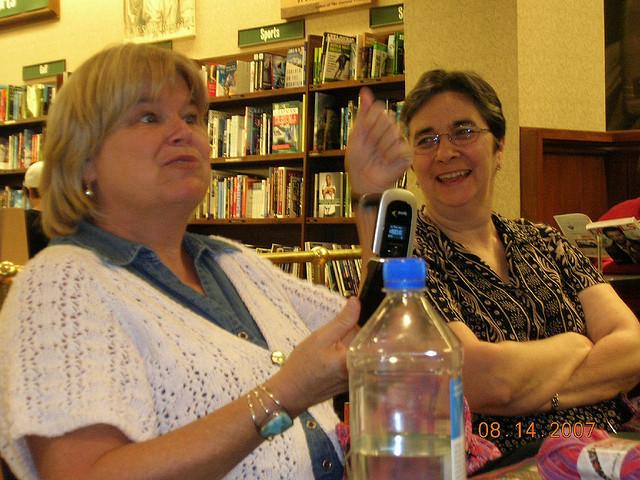Is anyone wearing earrings?
Short answer required. Yes. How old are the women?
Be succinct. 50s. What is the woman in white drinking?
Give a very brief answer. Water. 